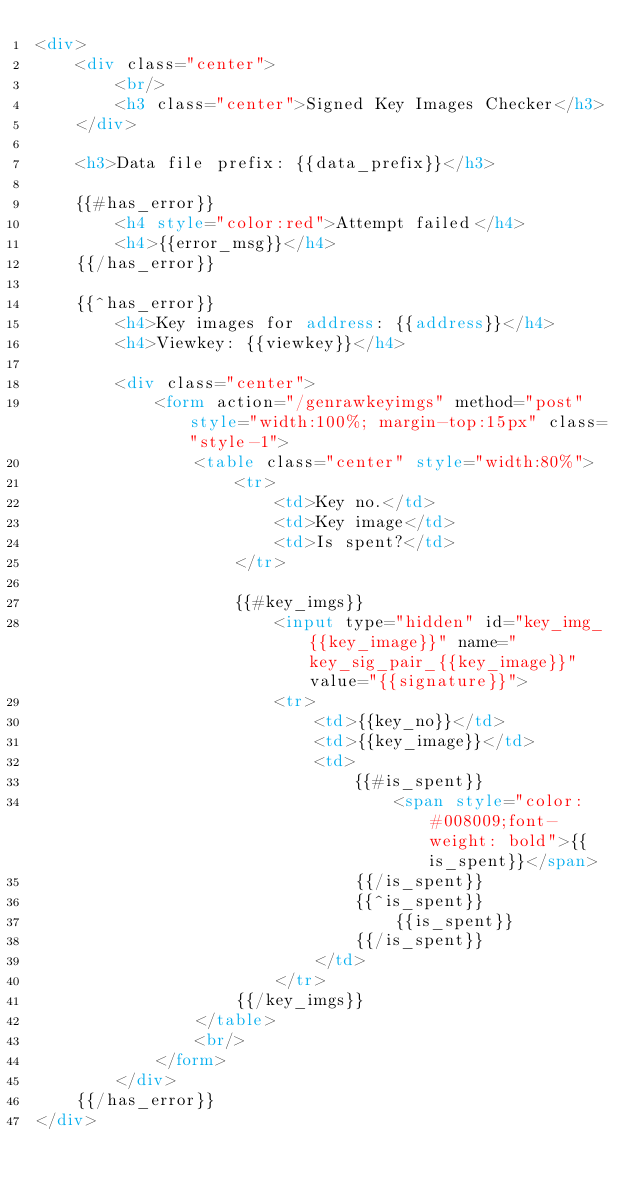<code> <loc_0><loc_0><loc_500><loc_500><_HTML_><div>
    <div class="center">
        <br/>
        <h3 class="center">Signed Key Images Checker</h3>
    </div>

    <h3>Data file prefix: {{data_prefix}}</h3>

    {{#has_error}}
        <h4 style="color:red">Attempt failed</h4>
        <h4>{{error_msg}}</h4>
    {{/has_error}}

    {{^has_error}}
        <h4>Key images for address: {{address}}</h4>
        <h4>Viewkey: {{viewkey}}</h4>

        <div class="center">
            <form action="/genrawkeyimgs" method="post" style="width:100%; margin-top:15px" class="style-1">
                <table class="center" style="width:80%">
                    <tr>
                        <td>Key no.</td>
                        <td>Key image</td>
                        <td>Is spent?</td>
                    </tr>

                    {{#key_imgs}}
                        <input type="hidden" id="key_img_{{key_image}}" name="key_sig_pair_{{key_image}}" value="{{signature}}">
                        <tr>
                            <td>{{key_no}}</td>
                            <td>{{key_image}}</td>
                            <td>
                                {{#is_spent}}
                                    <span style="color: #008009;font-weight: bold">{{is_spent}}</span>
                                {{/is_spent}}
                                {{^is_spent}}
                                    {{is_spent}}
                                {{/is_spent}}
                            </td>
                        </tr>
                    {{/key_imgs}}
                </table>
                <br/>
            </form>
        </div>
    {{/has_error}}
</div></code> 